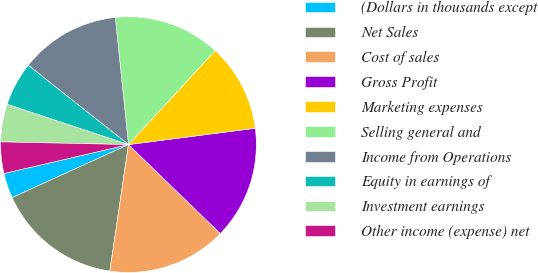<chart> <loc_0><loc_0><loc_500><loc_500><pie_chart><fcel>(Dollars in thousands except<fcel>Net Sales<fcel>Cost of sales<fcel>Gross Profit<fcel>Marketing expenses<fcel>Selling general and<fcel>Income from Operations<fcel>Equity in earnings of<fcel>Investment earnings<fcel>Other income (expense) net<nl><fcel>3.17%<fcel>15.87%<fcel>15.08%<fcel>14.29%<fcel>11.11%<fcel>13.49%<fcel>12.7%<fcel>5.56%<fcel>4.76%<fcel>3.97%<nl></chart> 